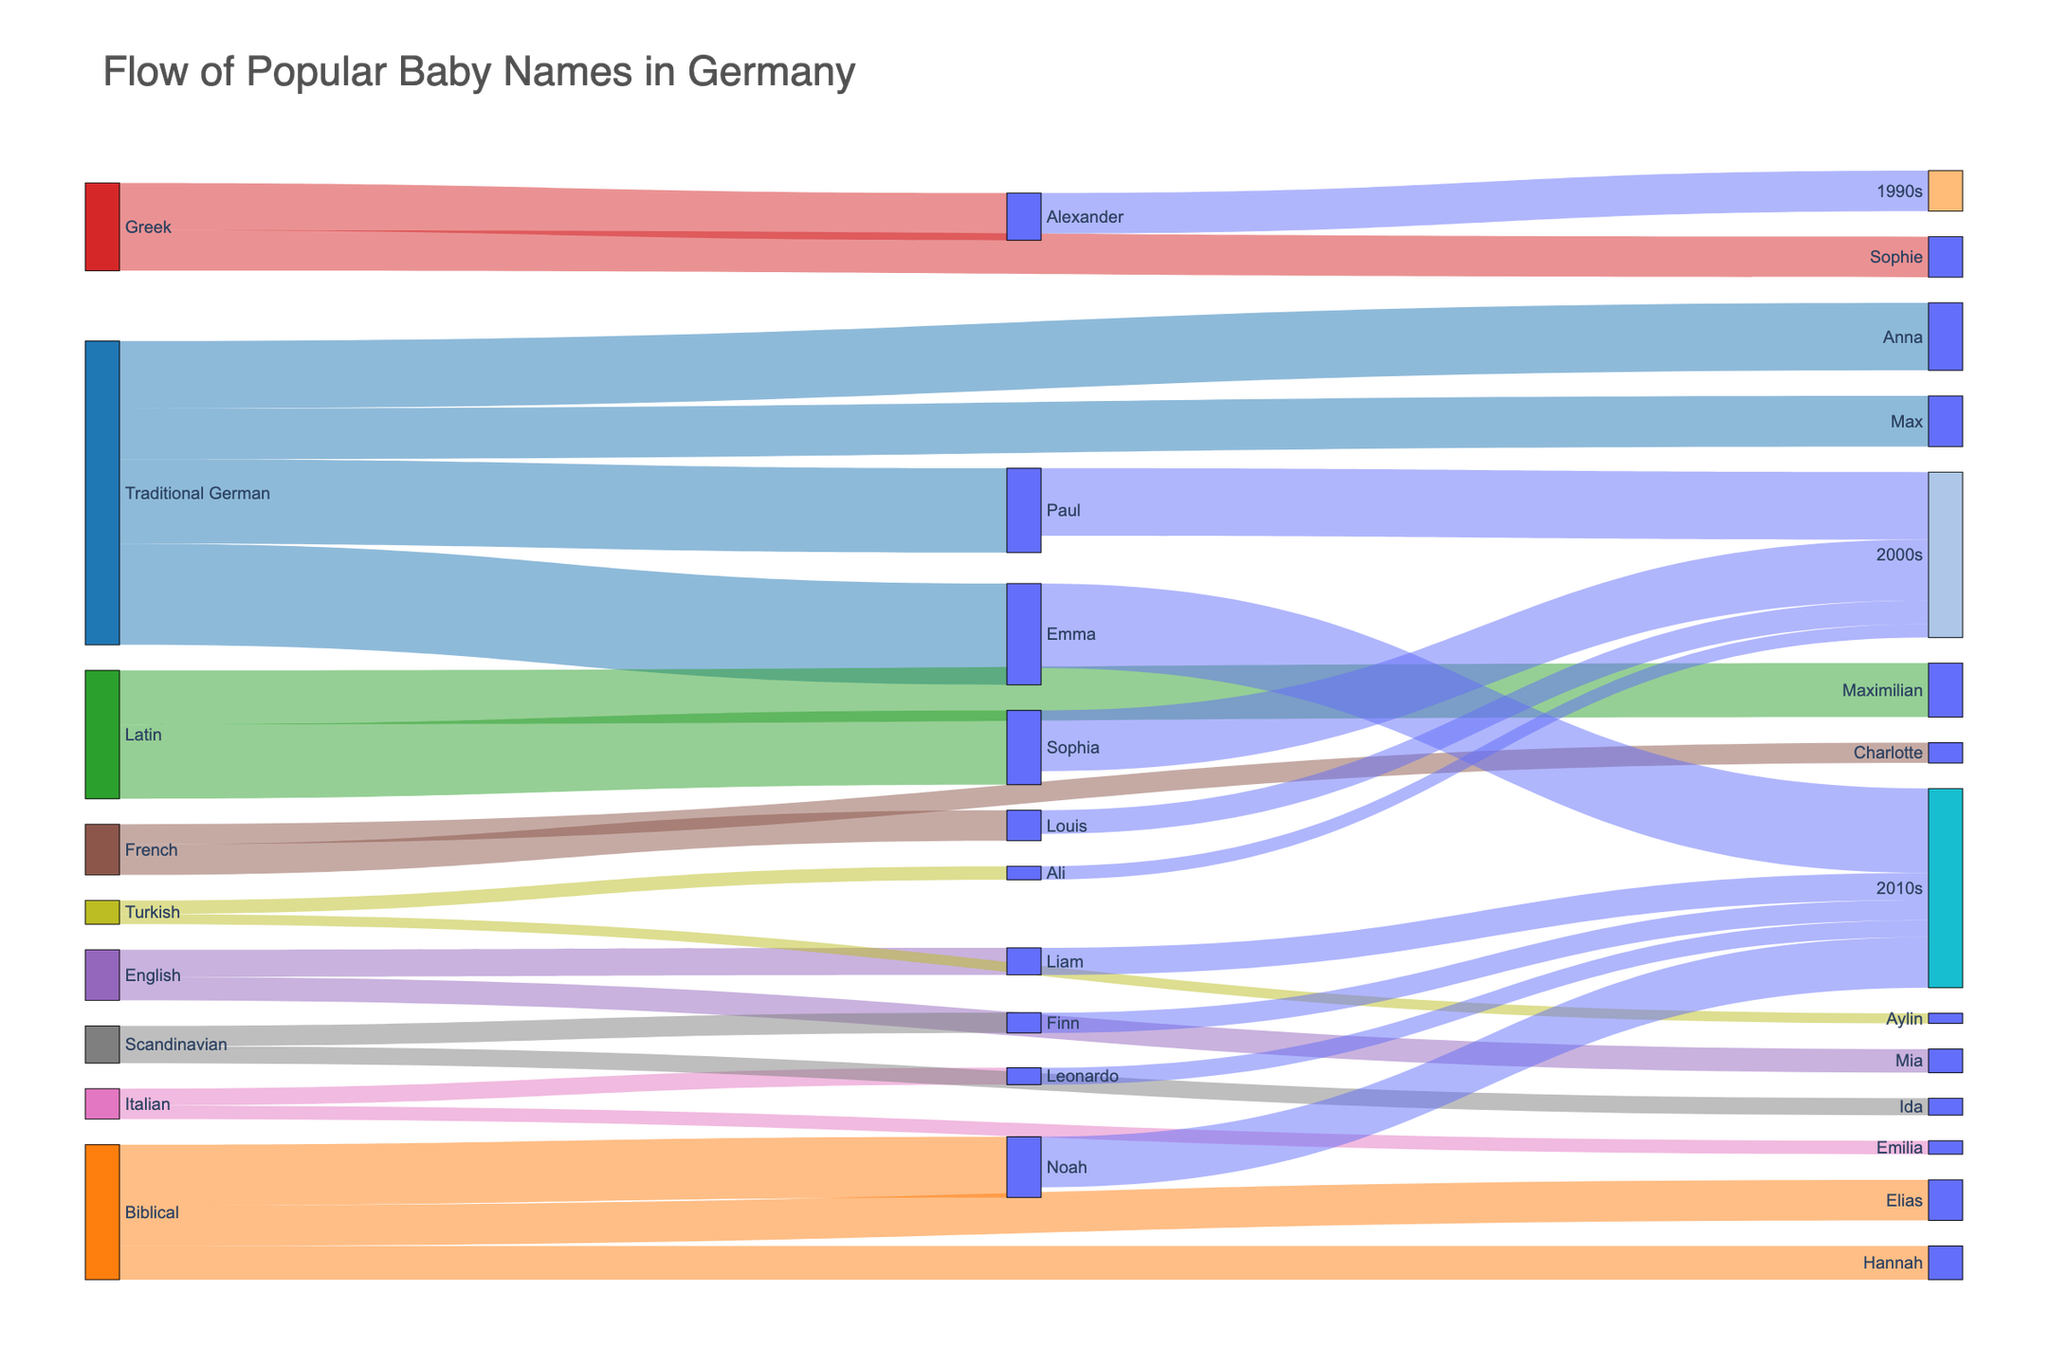What's the most common origin for popular baby names in Germany in the dataset? The Sankey diagram shows the flow of names from their origins. By looking at the thickness of the flows, "Traditional German" has the largest combined flow.
Answer: Traditional German Which baby's name appears in both the 2000s and the 2010s? Examine the links connecting names to decades; "Emma" appears linked to both the 2000s and 2010s.
Answer: Emma How many baby names are influenced by Latin origins? By checking the flows connected to the label "Latin," you can count two names: Sophia and Maximilian.
Answer: 2 Which origin has the least influence on popular baby names in Germany? Check for the thinnest connections; "Turkish" has the smallest combined flow with two names, Ali and Aylin.
Answer: Turkish What is the total value of names influenced by the Biblical origin? Sum the values of flows connected to "Biblical": Noah (18), Elias (12), and Hannah (10). The total is 18 + 12 + 10 = 40.
Answer: 40 Which baby name has the highest value from the "Traditional German" origin, and what is it? Look at the flows from "Traditional German" and compare their values; "Emma" has the highest value at 30.
Answer: Emma, 30 How many origins influence baby names in the 2010s? Follow the flows leading to the 2010s and count the distinct origins: Traditional German, Biblical, English, Greek, Italian, and Scandinavian.
Answer: 6 Is the flow value from "Traditional German" in the 2010s higher than that from the 2000s? Compare the sum of values from "Traditional German": In the 2010s (Emma - 25) and 2000s (Paul - 20). Yes, 25 (2010s) is greater than 20 (2000s).
Answer: Yes Which name appears in the 1990s and what is its origin? Locate the flow leading to the 1990s; "Alexander" with Greek origin is connected there.
Answer: Alexander, Greek 